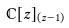<formula> <loc_0><loc_0><loc_500><loc_500>\mathbb { C } [ z ] _ { ( z - 1 ) }</formula> 